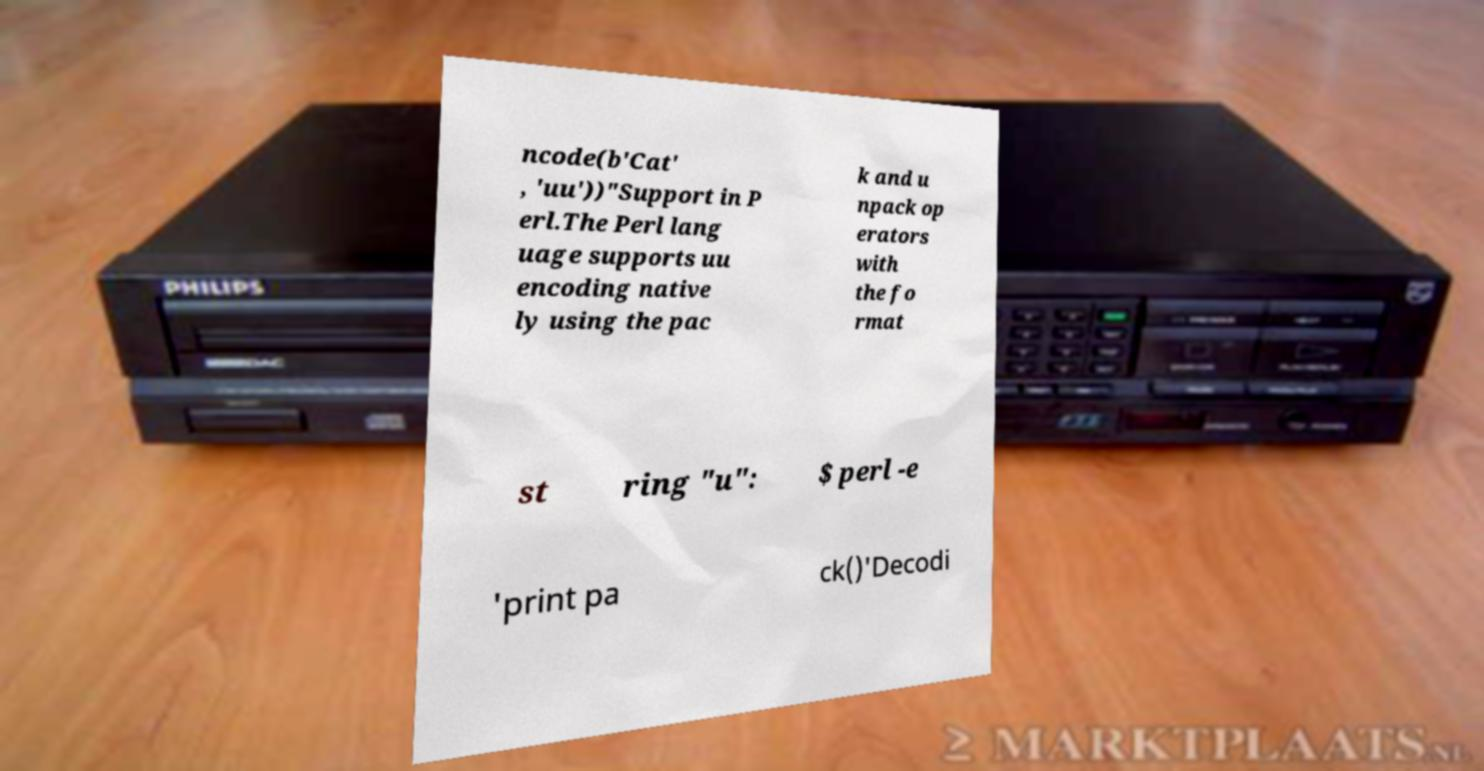There's text embedded in this image that I need extracted. Can you transcribe it verbatim? ncode(b'Cat' , 'uu'))"Support in P erl.The Perl lang uage supports uu encoding native ly using the pac k and u npack op erators with the fo rmat st ring "u": $ perl -e 'print pa ck()'Decodi 